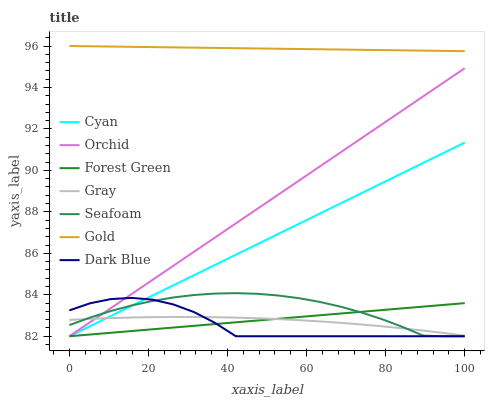Does Dark Blue have the minimum area under the curve?
Answer yes or no. Yes. Does Gold have the maximum area under the curve?
Answer yes or no. Yes. Does Seafoam have the minimum area under the curve?
Answer yes or no. No. Does Seafoam have the maximum area under the curve?
Answer yes or no. No. Is Orchid the smoothest?
Answer yes or no. Yes. Is Dark Blue the roughest?
Answer yes or no. Yes. Is Gold the smoothest?
Answer yes or no. No. Is Gold the roughest?
Answer yes or no. No. Does Seafoam have the lowest value?
Answer yes or no. Yes. Does Gold have the lowest value?
Answer yes or no. No. Does Gold have the highest value?
Answer yes or no. Yes. Does Seafoam have the highest value?
Answer yes or no. No. Is Cyan less than Gold?
Answer yes or no. Yes. Is Gold greater than Seafoam?
Answer yes or no. Yes. Does Cyan intersect Orchid?
Answer yes or no. Yes. Is Cyan less than Orchid?
Answer yes or no. No. Is Cyan greater than Orchid?
Answer yes or no. No. Does Cyan intersect Gold?
Answer yes or no. No. 